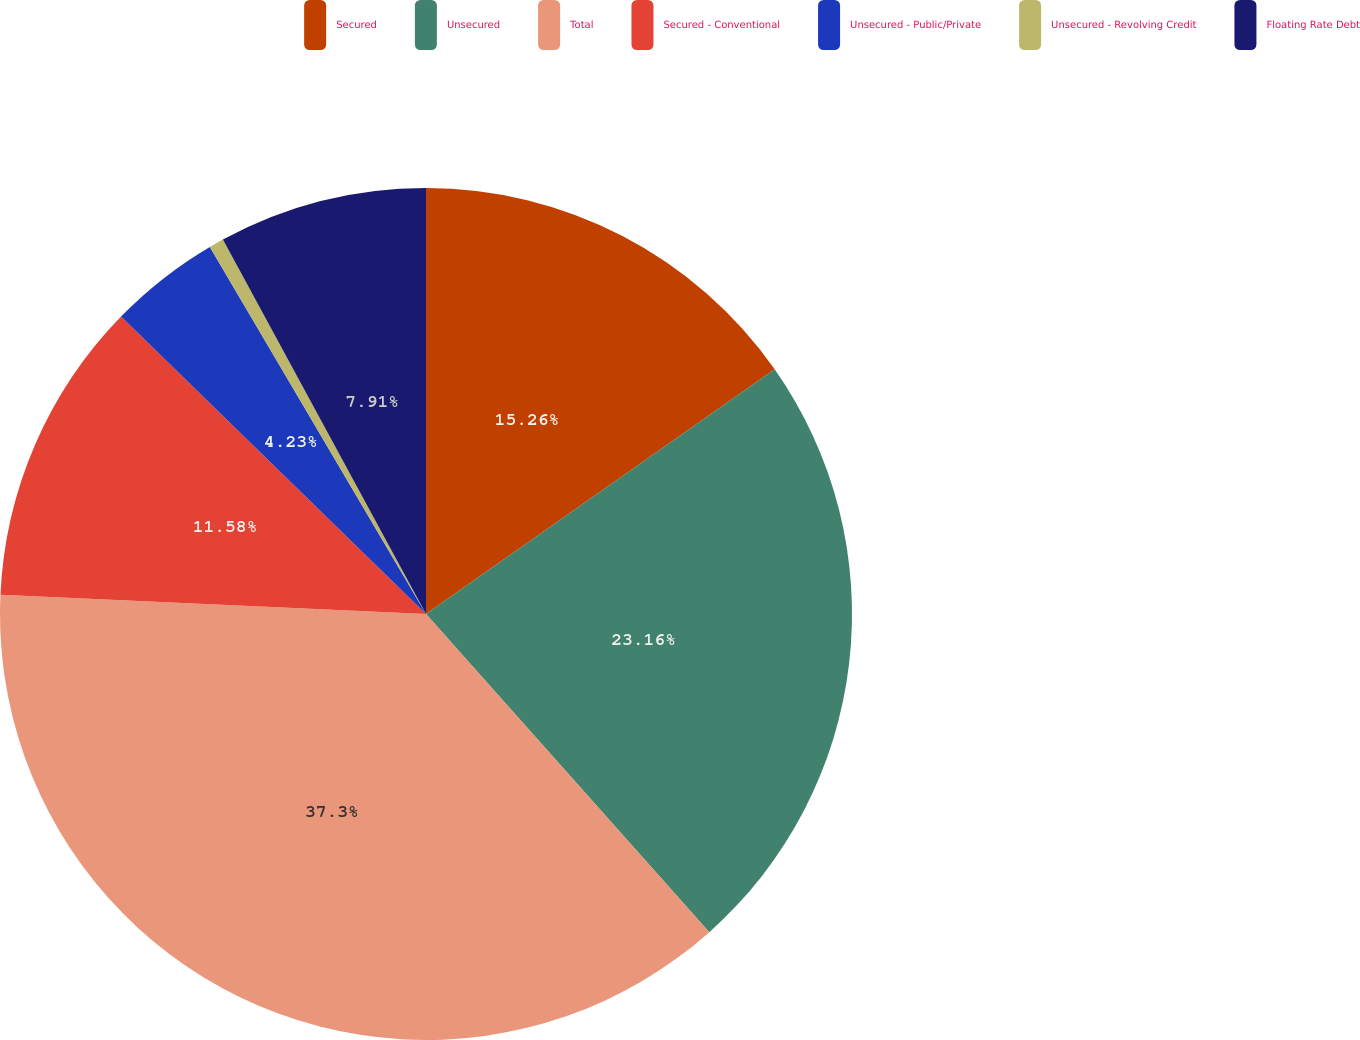Convert chart. <chart><loc_0><loc_0><loc_500><loc_500><pie_chart><fcel>Secured<fcel>Unsecured<fcel>Total<fcel>Secured - Conventional<fcel>Unsecured - Public/Private<fcel>Unsecured - Revolving Credit<fcel>Floating Rate Debt<nl><fcel>15.26%<fcel>23.16%<fcel>37.3%<fcel>11.58%<fcel>4.23%<fcel>0.56%<fcel>7.91%<nl></chart> 